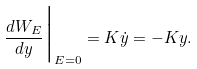<formula> <loc_0><loc_0><loc_500><loc_500>\frac { d W _ { E } } { d y } \Big | _ { E = 0 } = K \dot { y } = - K y .</formula> 